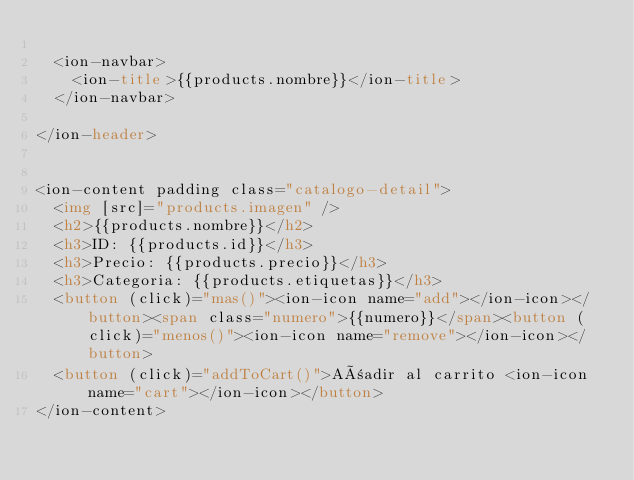Convert code to text. <code><loc_0><loc_0><loc_500><loc_500><_HTML_>
  <ion-navbar>
    <ion-title>{{products.nombre}}</ion-title>
  </ion-navbar>

</ion-header>


<ion-content padding class="catalogo-detail">
  <img [src]="products.imagen" />
  <h2>{{products.nombre}}</h2>
  <h3>ID: {{products.id}}</h3>
  <h3>Precio: {{products.precio}}</h3>
  <h3>Categoria: {{products.etiquetas}}</h3>
  <button (click)="mas()"><ion-icon name="add"></ion-icon></button><span class="numero">{{numero}}</span><button (click)="menos()"><ion-icon name="remove"></ion-icon></button>
  <button (click)="addToCart()">Añadir al carrito <ion-icon name="cart"></ion-icon></button>
</ion-content>
</code> 